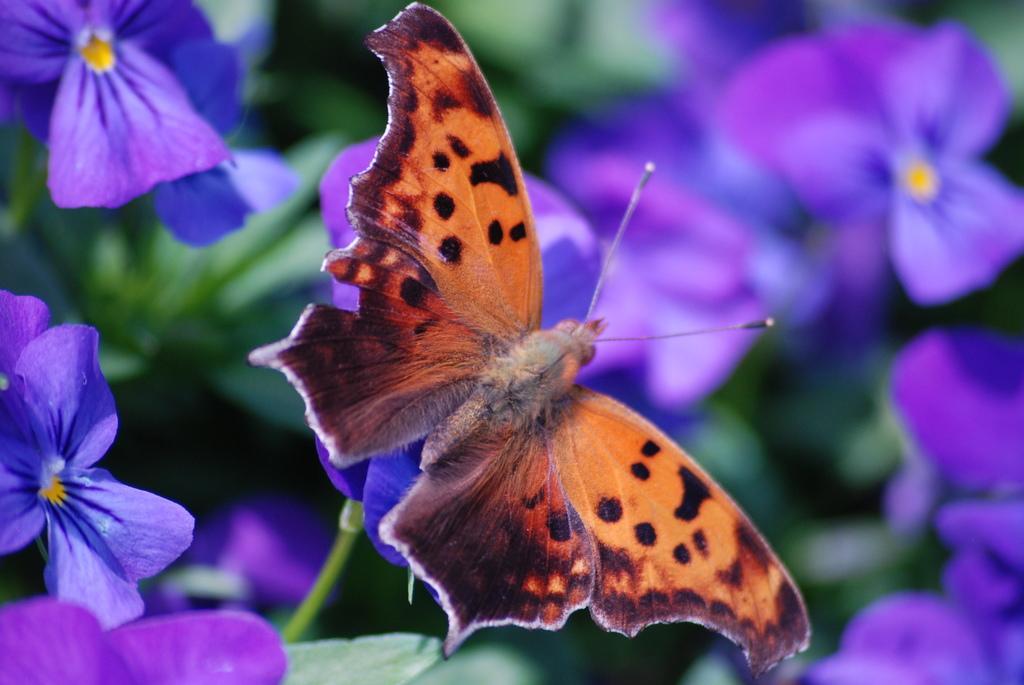Could you give a brief overview of what you see in this image? In this image we can see a butterfly on the flower and blur background. 